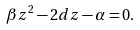<formula> <loc_0><loc_0><loc_500><loc_500>\beta z ^ { 2 } - 2 d z - \alpha = 0 .</formula> 